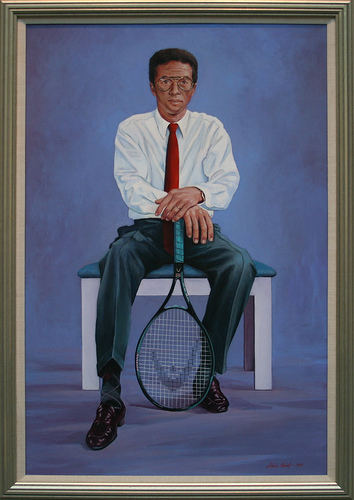What if the painting depicted the man holding a golden racket? How would that change the perception of the image? If the man were holding a golden racket, it would add a symbolic layer to the image, suggesting triumph, excellence, and perhaps a lifetime achievement. The golden hue would highlight the man's significance in the sport, elevating the image from a simple portrait to a homage to his legacy. 